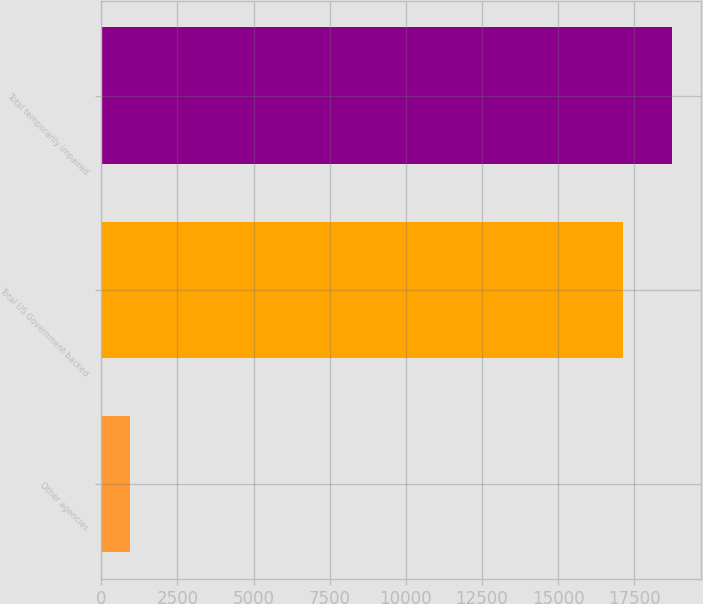Convert chart to OTSL. <chart><loc_0><loc_0><loc_500><loc_500><bar_chart><fcel>Other agencies<fcel>Total US Government backed<fcel>Total temporarily impaired<nl><fcel>952<fcel>17138<fcel>18756.6<nl></chart> 